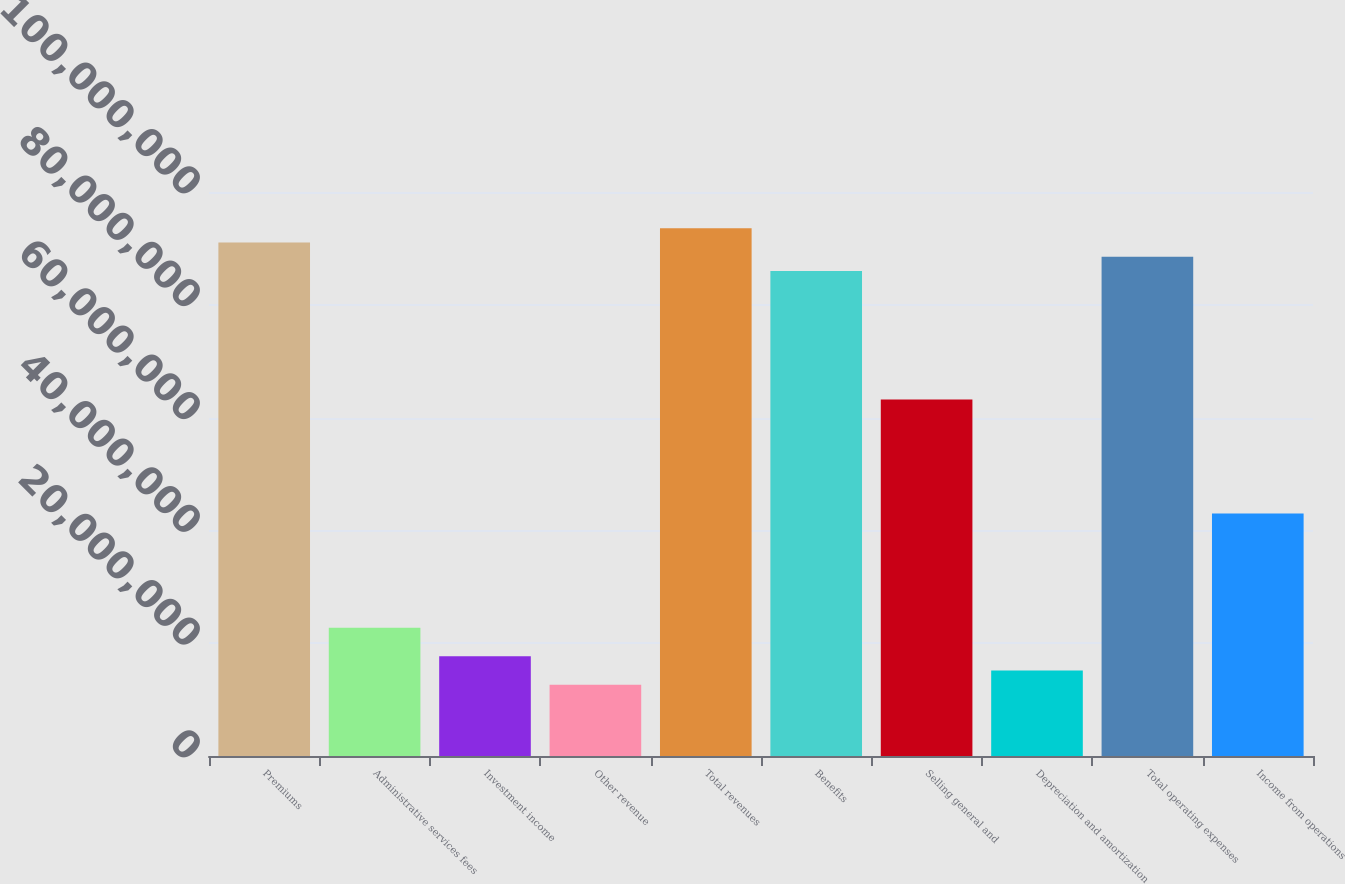<chart> <loc_0><loc_0><loc_500><loc_500><bar_chart><fcel>Premiums<fcel>Administrative services fees<fcel>Investment income<fcel>Other revenue<fcel>Total revenues<fcel>Benefits<fcel>Selling general and<fcel>Depreciation and amortization<fcel>Total operating expenses<fcel>Income from operations<nl><fcel>9.10439e+07<fcel>2.2761e+07<fcel>1.7703e+07<fcel>1.2645e+07<fcel>9.35729e+07<fcel>8.5986e+07<fcel>6.3225e+07<fcel>1.5174e+07<fcel>8.85149e+07<fcel>4.2993e+07<nl></chart> 